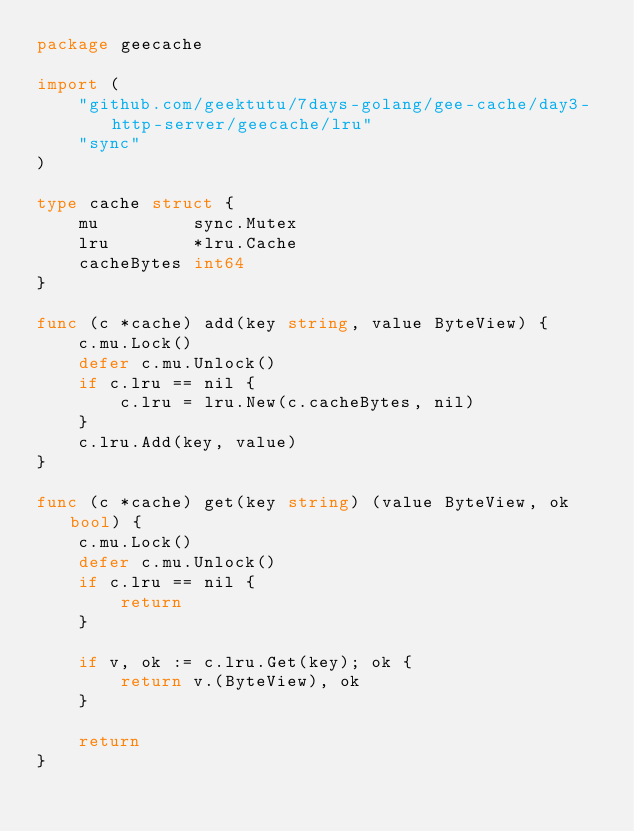<code> <loc_0><loc_0><loc_500><loc_500><_Go_>package geecache

import (
	"github.com/geektutu/7days-golang/gee-cache/day3-http-server/geecache/lru"
	"sync"
)

type cache struct {
	mu         sync.Mutex
	lru        *lru.Cache
	cacheBytes int64
}

func (c *cache) add(key string, value ByteView) {
	c.mu.Lock()
	defer c.mu.Unlock()
	if c.lru == nil {
		c.lru = lru.New(c.cacheBytes, nil)
	}
	c.lru.Add(key, value)
}

func (c *cache) get(key string) (value ByteView, ok bool) {
	c.mu.Lock()
	defer c.mu.Unlock()
	if c.lru == nil {
		return
	}

	if v, ok := c.lru.Get(key); ok {
		return v.(ByteView), ok
	}

	return
}
</code> 